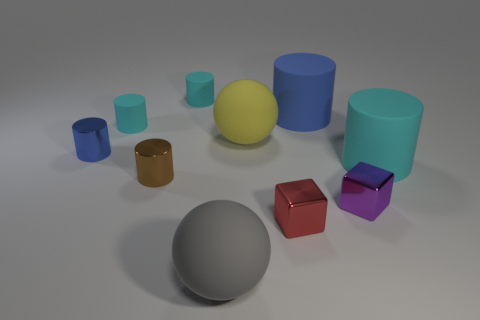Do the blue matte object and the yellow ball have the same size? From the perspective of the image, it appears that the blue matte object and the yellow ball are roughly the same size, although without exact measurements, this cannot be confirmed with absolute certainty. 